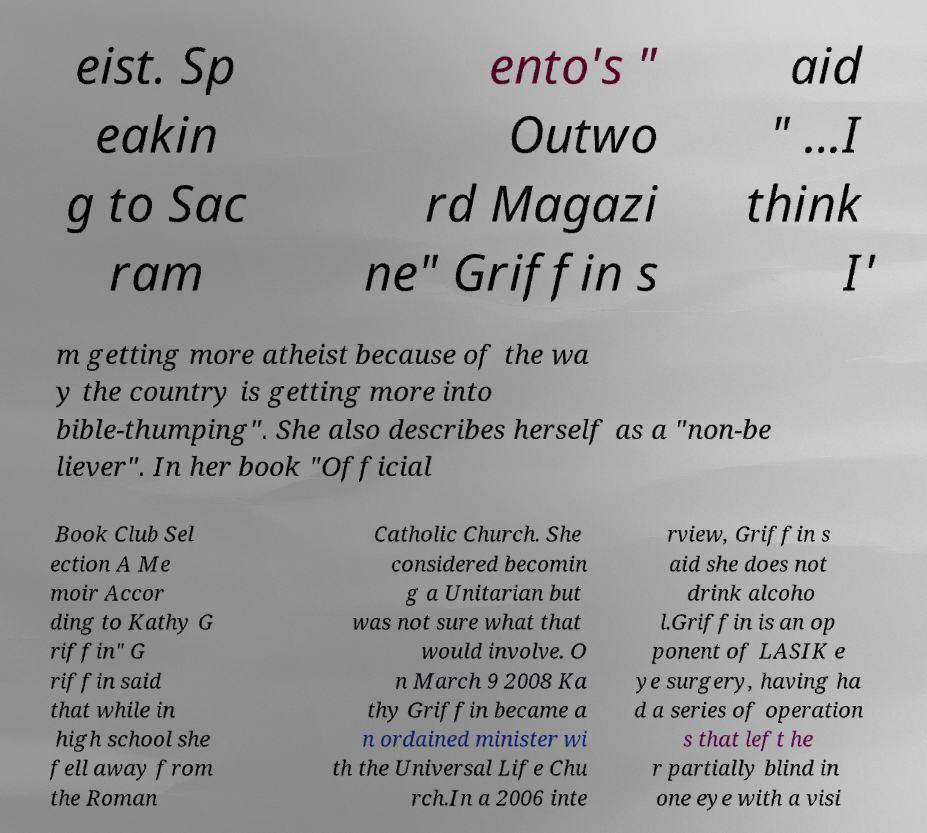Can you accurately transcribe the text from the provided image for me? eist. Sp eakin g to Sac ram ento's " Outwo rd Magazi ne" Griffin s aid " ...I think I' m getting more atheist because of the wa y the country is getting more into bible-thumping". She also describes herself as a "non-be liever". In her book "Official Book Club Sel ection A Me moir Accor ding to Kathy G riffin" G riffin said that while in high school she fell away from the Roman Catholic Church. She considered becomin g a Unitarian but was not sure what that would involve. O n March 9 2008 Ka thy Griffin became a n ordained minister wi th the Universal Life Chu rch.In a 2006 inte rview, Griffin s aid she does not drink alcoho l.Griffin is an op ponent of LASIK e ye surgery, having ha d a series of operation s that left he r partially blind in one eye with a visi 